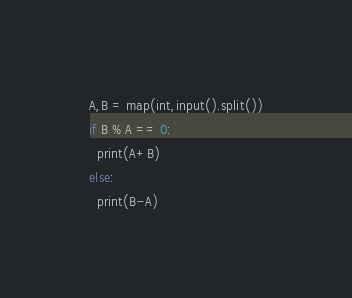Convert code to text. <code><loc_0><loc_0><loc_500><loc_500><_Python_>A,B = map(int,input().split())
if B % A == 0:
  print(A+B)
else:
  print(B-A)</code> 